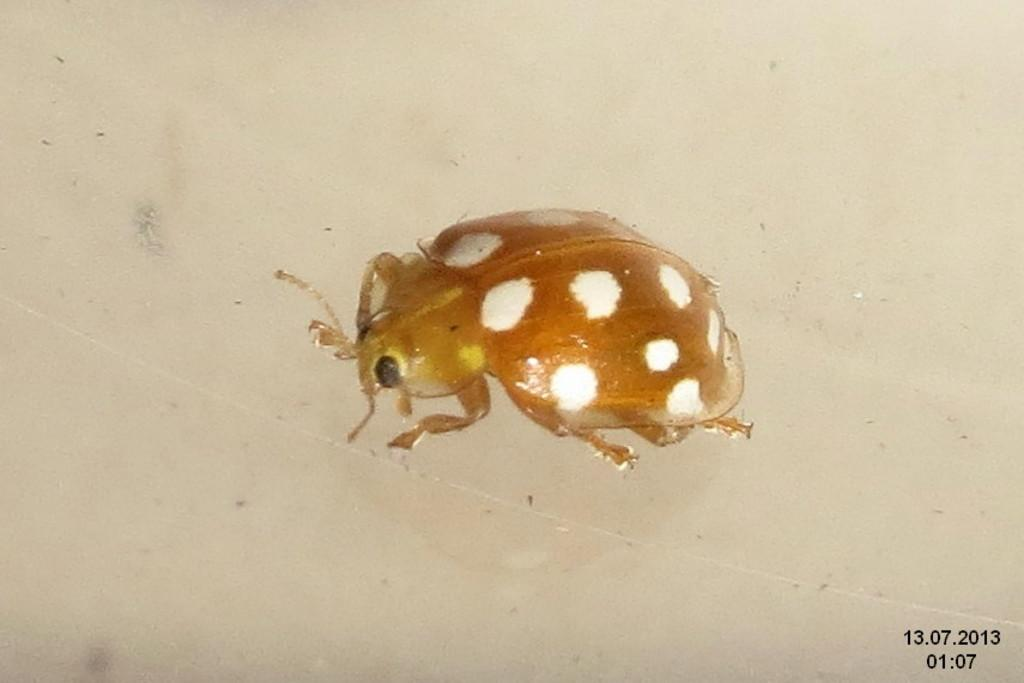What type of creature can be seen in the image? There is an insect in the image. What is the color of the insect? The insect is brown in color. What type of reward is the insect holding in the image? There is no reward present in the image, as it features an insect that is brown in color. 